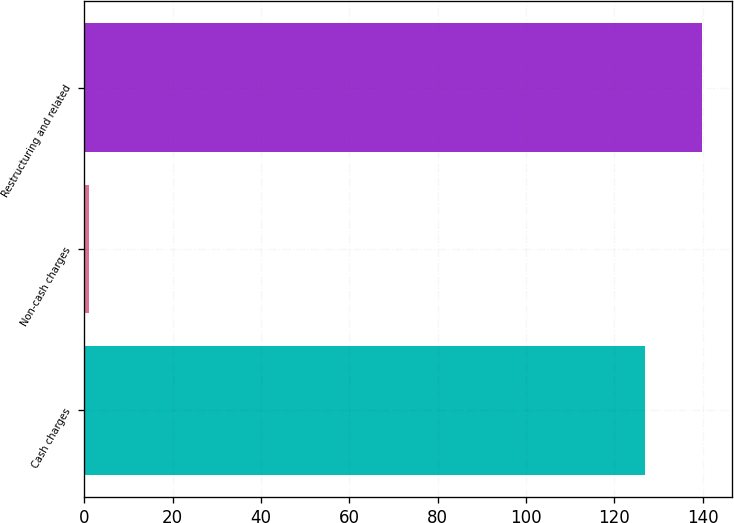Convert chart to OTSL. <chart><loc_0><loc_0><loc_500><loc_500><bar_chart><fcel>Cash charges<fcel>Non-cash charges<fcel>Restructuring and related<nl><fcel>127<fcel>1<fcel>139.7<nl></chart> 